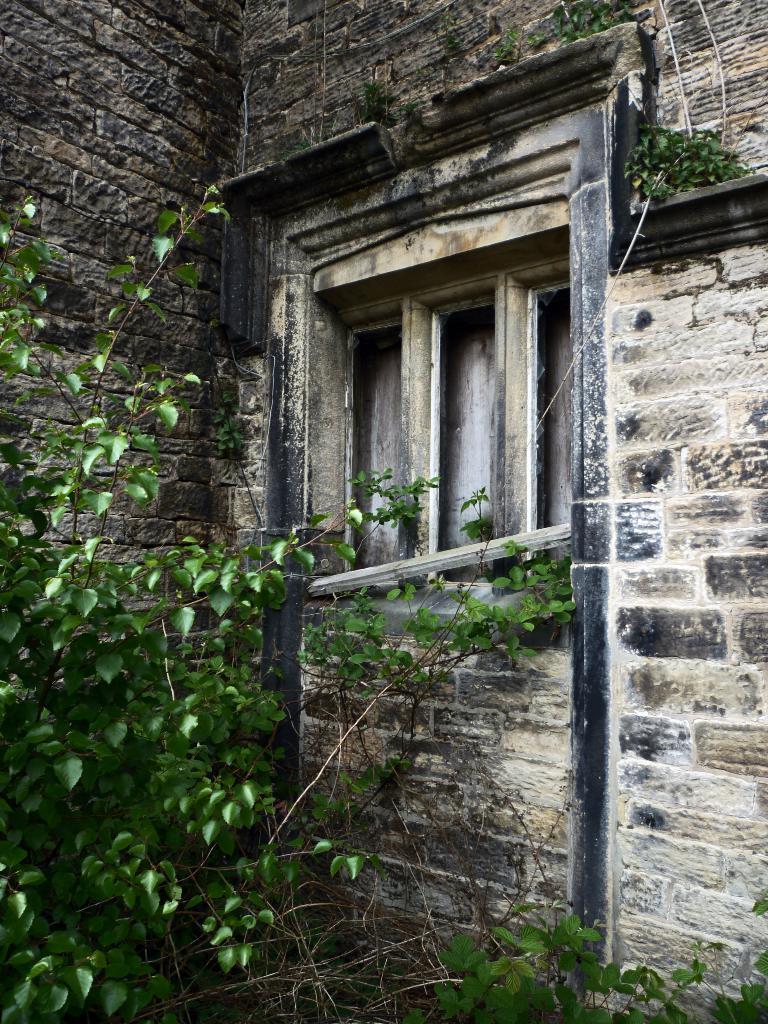Can you describe this image briefly? In the image we can see a building, made up of stones and this is a window of the building. Here we can see leaves. 